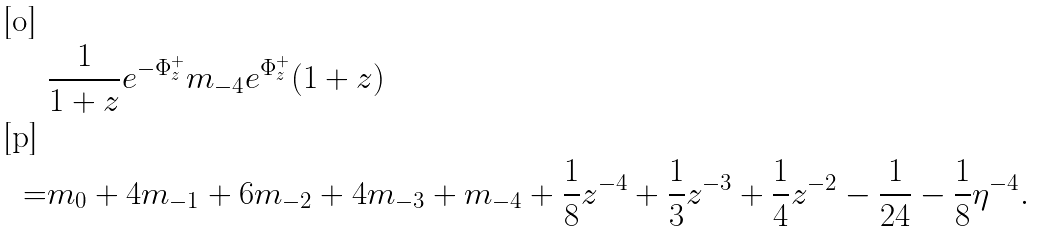<formula> <loc_0><loc_0><loc_500><loc_500>& \frac { 1 } { 1 + z } e ^ { - \Phi _ { z } ^ { + } } m _ { - 4 } e ^ { \Phi _ { z } ^ { + } } ( 1 + z ) \\ = & m _ { 0 } + 4 m _ { - 1 } + 6 m _ { - 2 } + 4 m _ { - 3 } + m _ { - 4 } + \frac { 1 } { 8 } z ^ { - 4 } + \frac { 1 } { 3 } z ^ { - 3 } + \frac { 1 } { 4 } z ^ { - 2 } - \frac { 1 } { 2 4 } - \frac { 1 } { 8 } \eta ^ { - 4 } .</formula> 